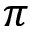Convert formula to latex. <formula><loc_0><loc_0><loc_500><loc_500>\pi</formula> 